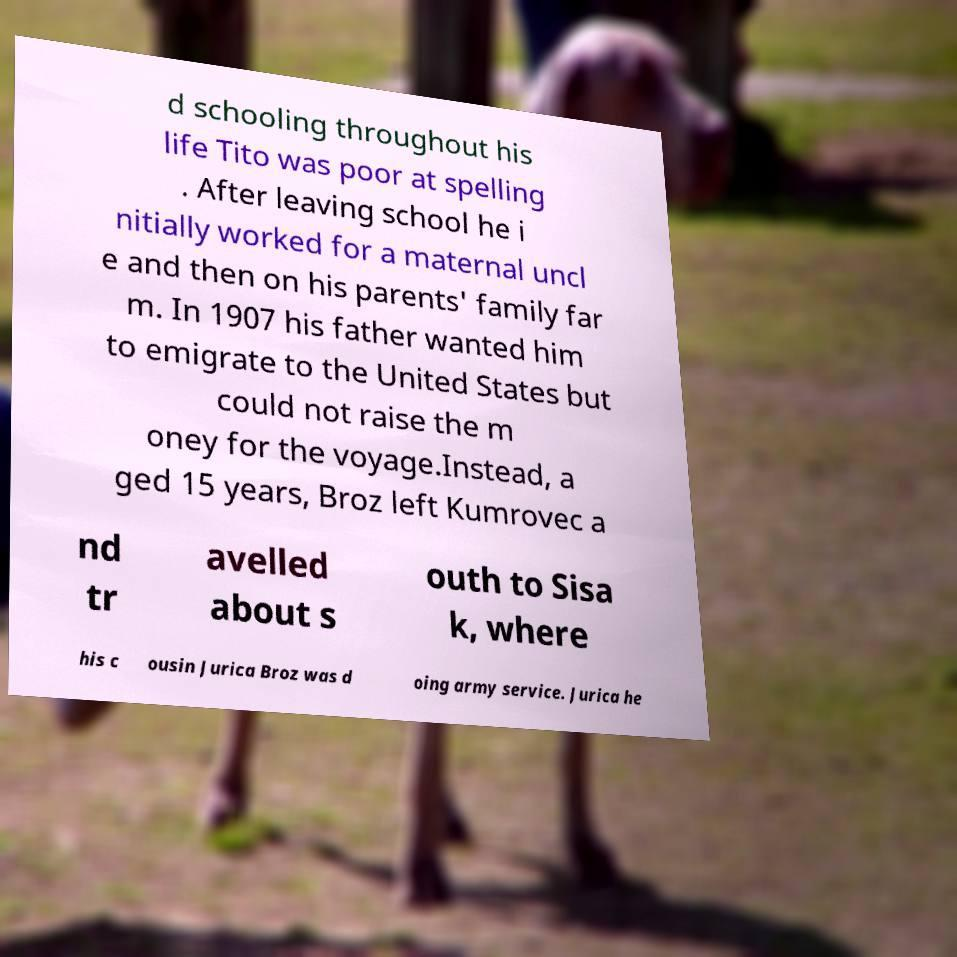Could you extract and type out the text from this image? d schooling throughout his life Tito was poor at spelling . After leaving school he i nitially worked for a maternal uncl e and then on his parents' family far m. In 1907 his father wanted him to emigrate to the United States but could not raise the m oney for the voyage.Instead, a ged 15 years, Broz left Kumrovec a nd tr avelled about s outh to Sisa k, where his c ousin Jurica Broz was d oing army service. Jurica he 